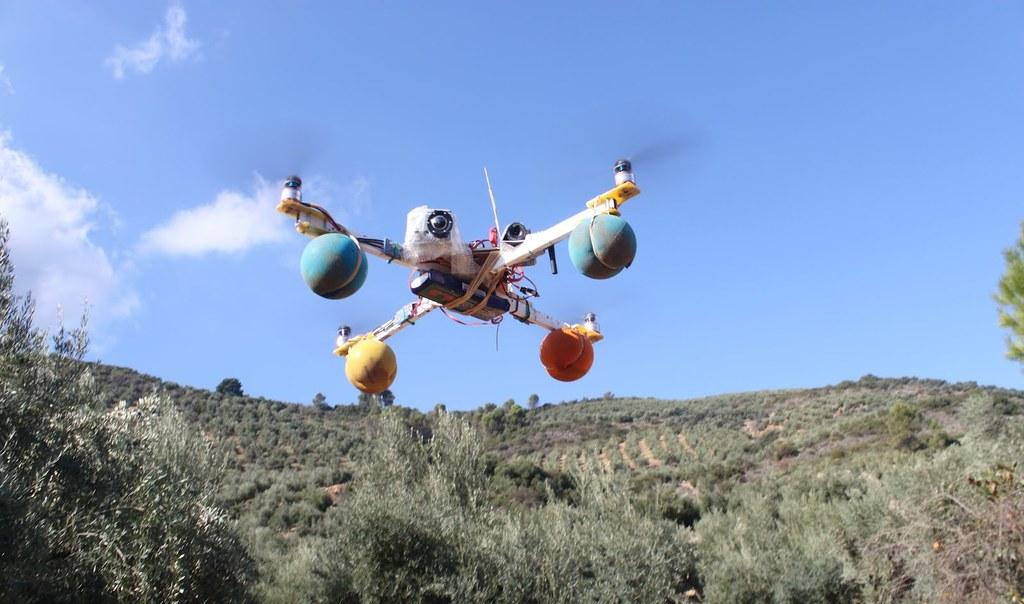What is the main subject in the center of the image? There is a drone camera in the center of the image. What type of vegetation can be seen at the bottom of the image? There are trees at the bottom of the image. What geographical features are visible in the background of the image? There are hills visible in the background of the image. What part of the natural environment is visible in the background of the image? The sky is visible in the background of the image. How does the drone camera help with the business in the image? The image does not show any business or context for the drone camera's use, so it is not possible to determine how it might help with a business. 